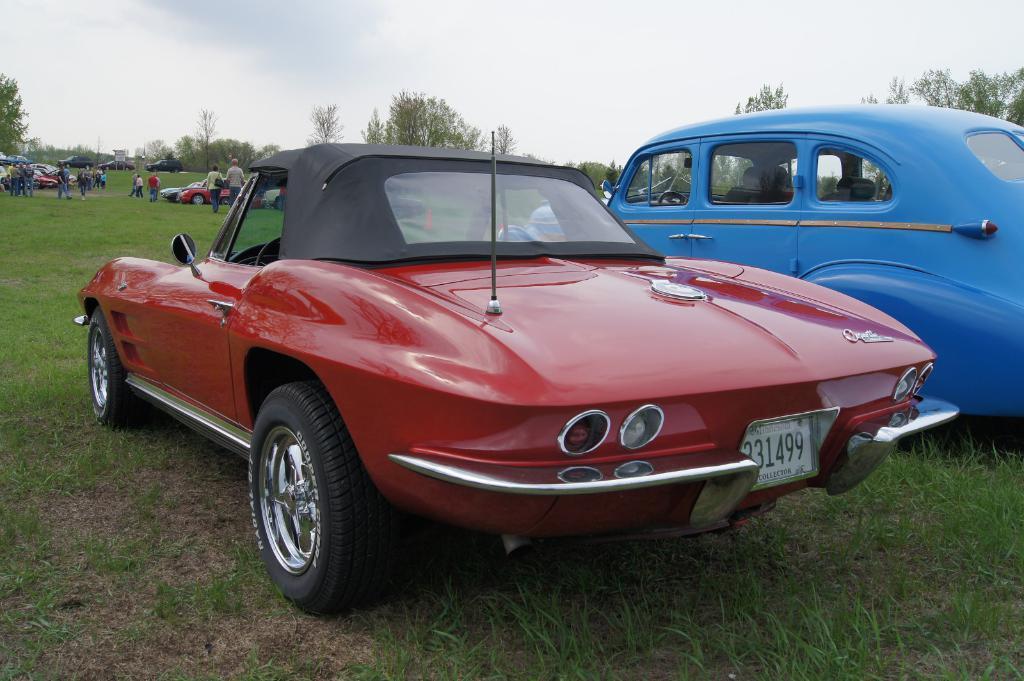Please provide a concise description of this image. In this image I can see a ground , on the ground I can see vehicles, persons, trees visible ,at the top there is the sky visible. 